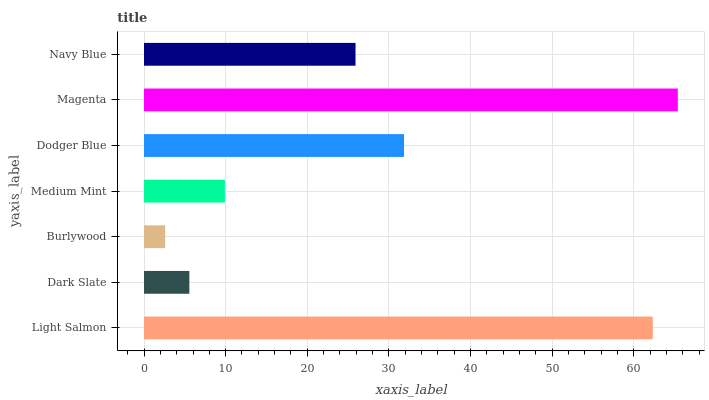Is Burlywood the minimum?
Answer yes or no. Yes. Is Magenta the maximum?
Answer yes or no. Yes. Is Dark Slate the minimum?
Answer yes or no. No. Is Dark Slate the maximum?
Answer yes or no. No. Is Light Salmon greater than Dark Slate?
Answer yes or no. Yes. Is Dark Slate less than Light Salmon?
Answer yes or no. Yes. Is Dark Slate greater than Light Salmon?
Answer yes or no. No. Is Light Salmon less than Dark Slate?
Answer yes or no. No. Is Navy Blue the high median?
Answer yes or no. Yes. Is Navy Blue the low median?
Answer yes or no. Yes. Is Medium Mint the high median?
Answer yes or no. No. Is Light Salmon the low median?
Answer yes or no. No. 